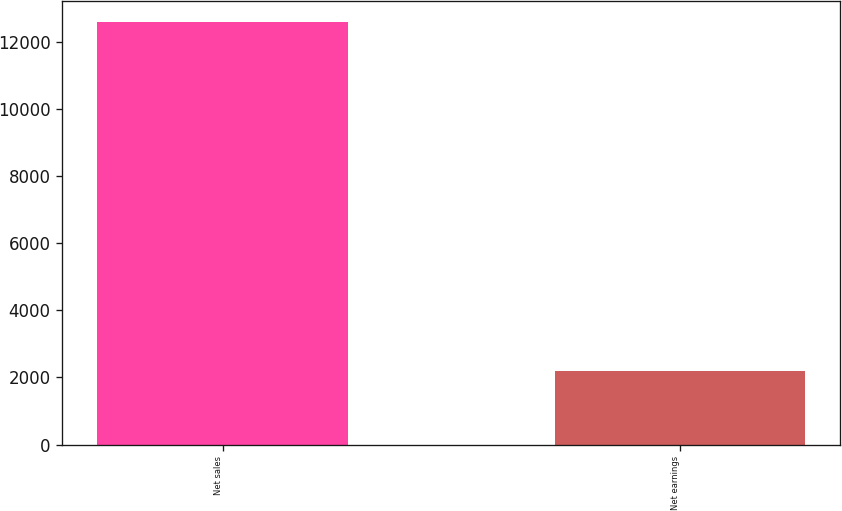Convert chart to OTSL. <chart><loc_0><loc_0><loc_500><loc_500><bar_chart><fcel>Net sales<fcel>Net earnings<nl><fcel>12608<fcel>2181<nl></chart> 